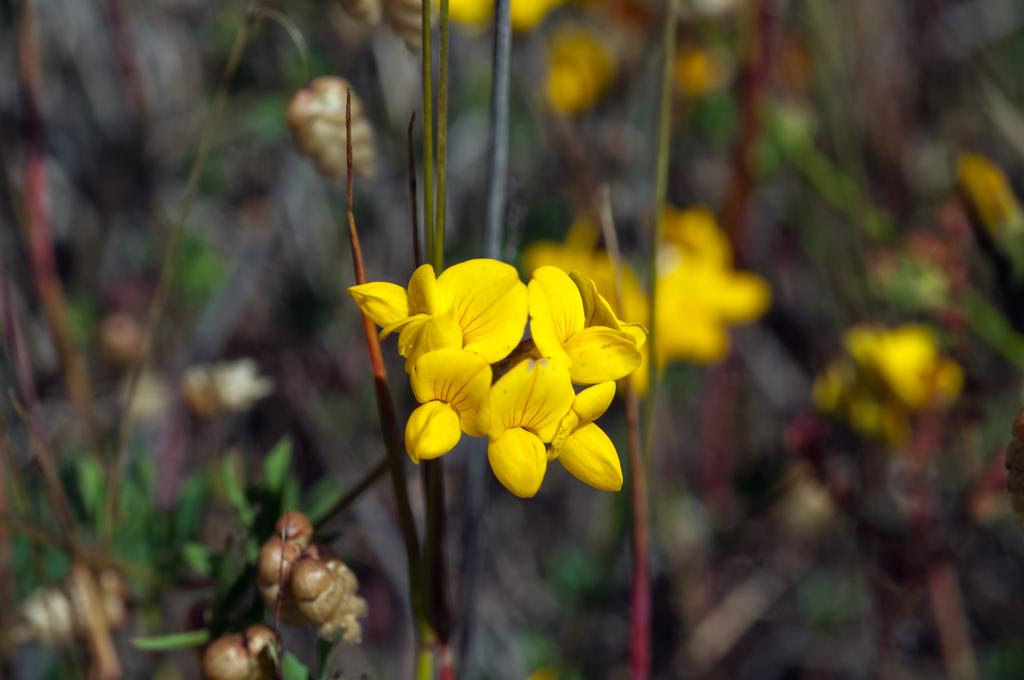What can be seen in the foreground of the picture? There are flowers and stems in the foreground of the picture. How would you describe the background of the picture? The background of the picture is blurred. What types of plants are visible in the background of the picture? There are plants, flowers, and buds in the background of the picture. What type of bear can be seen interacting with the flowers in the image? There is no bear present in the image; it features flowers and plants. Is there any motion or movement captured in the image? The image does not depict any motion or movement; it is a still image of flowers and plants. 